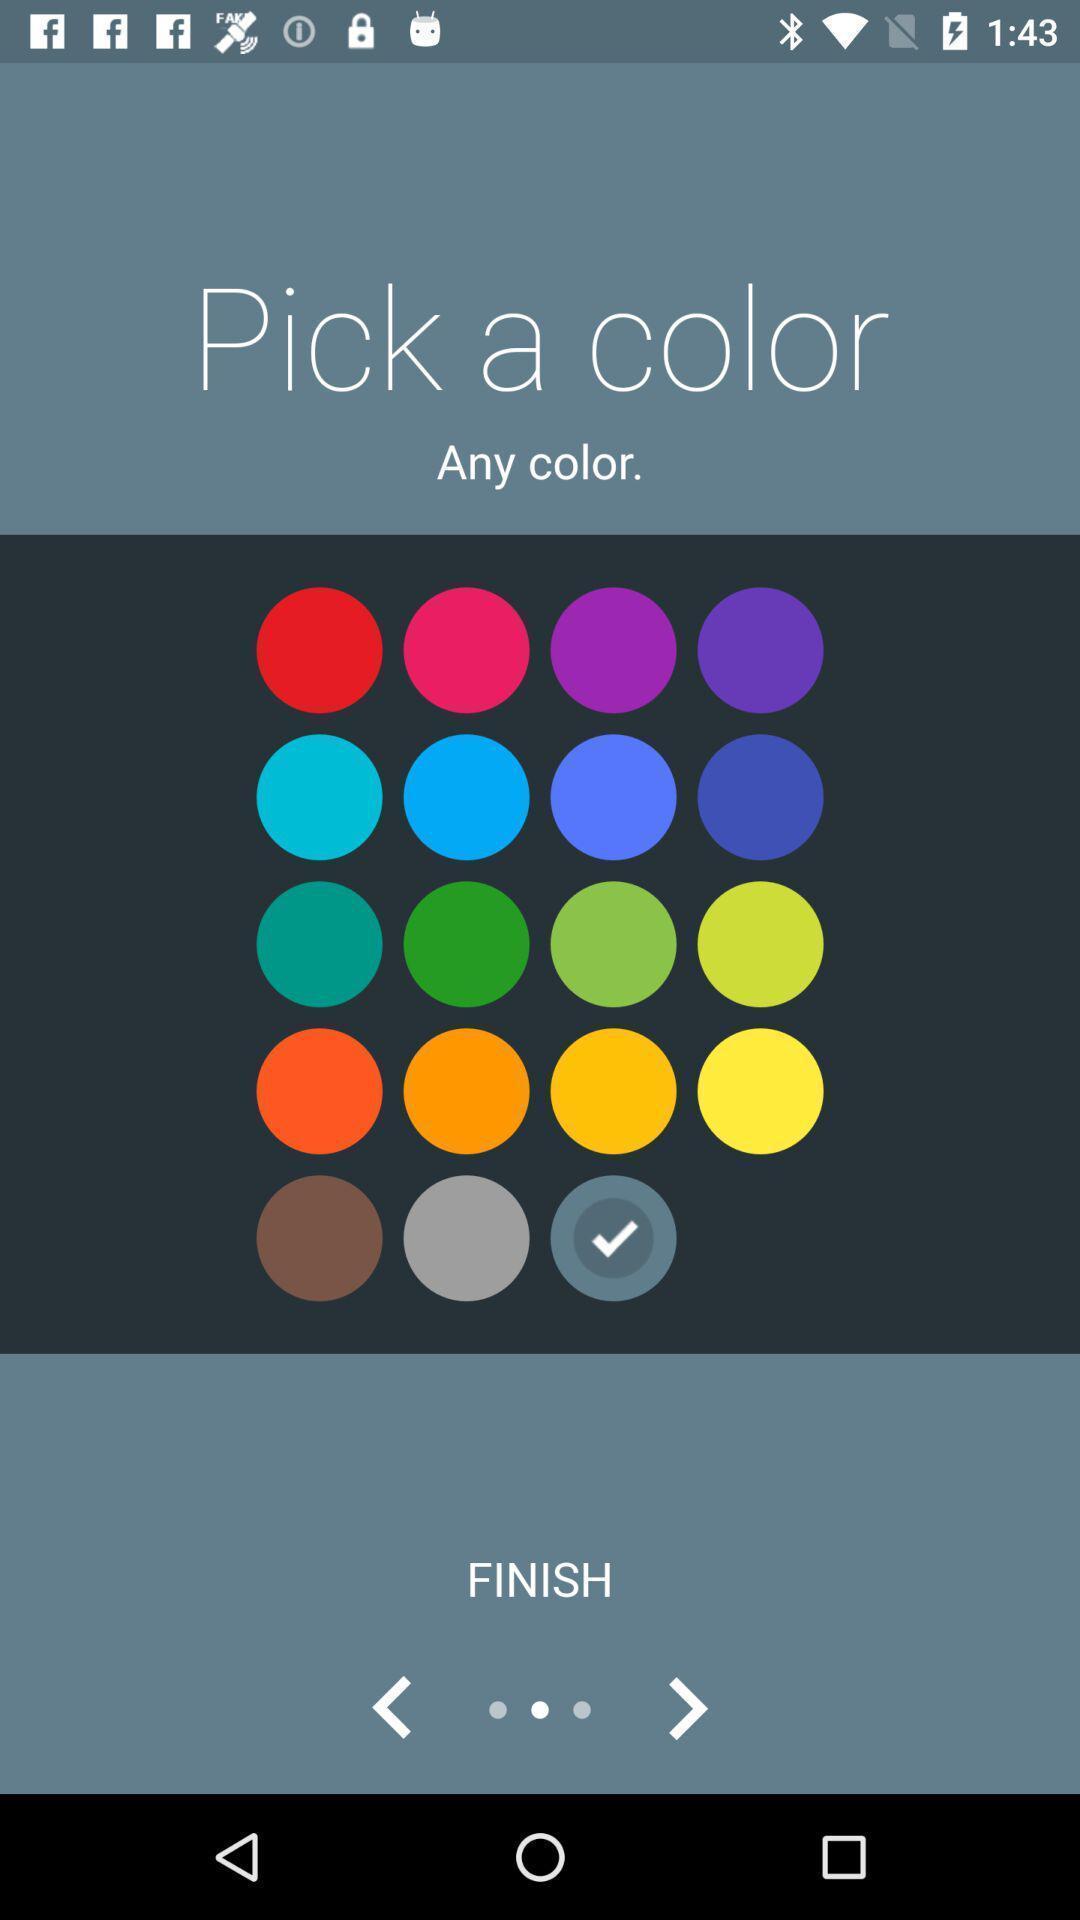Explain what's happening in this screen capture. Screen shows multiple options. 